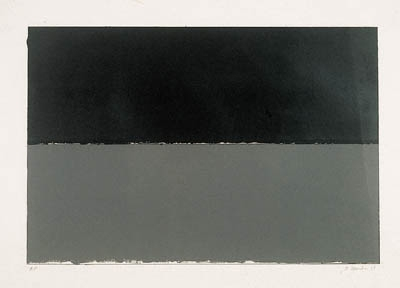Can you describe the main features of this image for me? The image presents an exemplar of minimalist art, showcasing two distinct rectangles stacked vertically. The top rectangle is saturated in deep black, while the bottom one has a muted gray hue. A thin, crisp white line subtly separates these sections, enhancing the visual contrast and drawing attention to the simplicity and precision of the composition. This piece epitomizes minimalism not only through its use of basic geometric forms and limited color palette but also through its invitation to find depth and narrative in austerity. The starkness could be seen as a reflection on solitude, boundaries, or introspection, encouraging a deeper viewer engagement beyond aesthetic appreciation. 